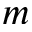<formula> <loc_0><loc_0><loc_500><loc_500>m</formula> 